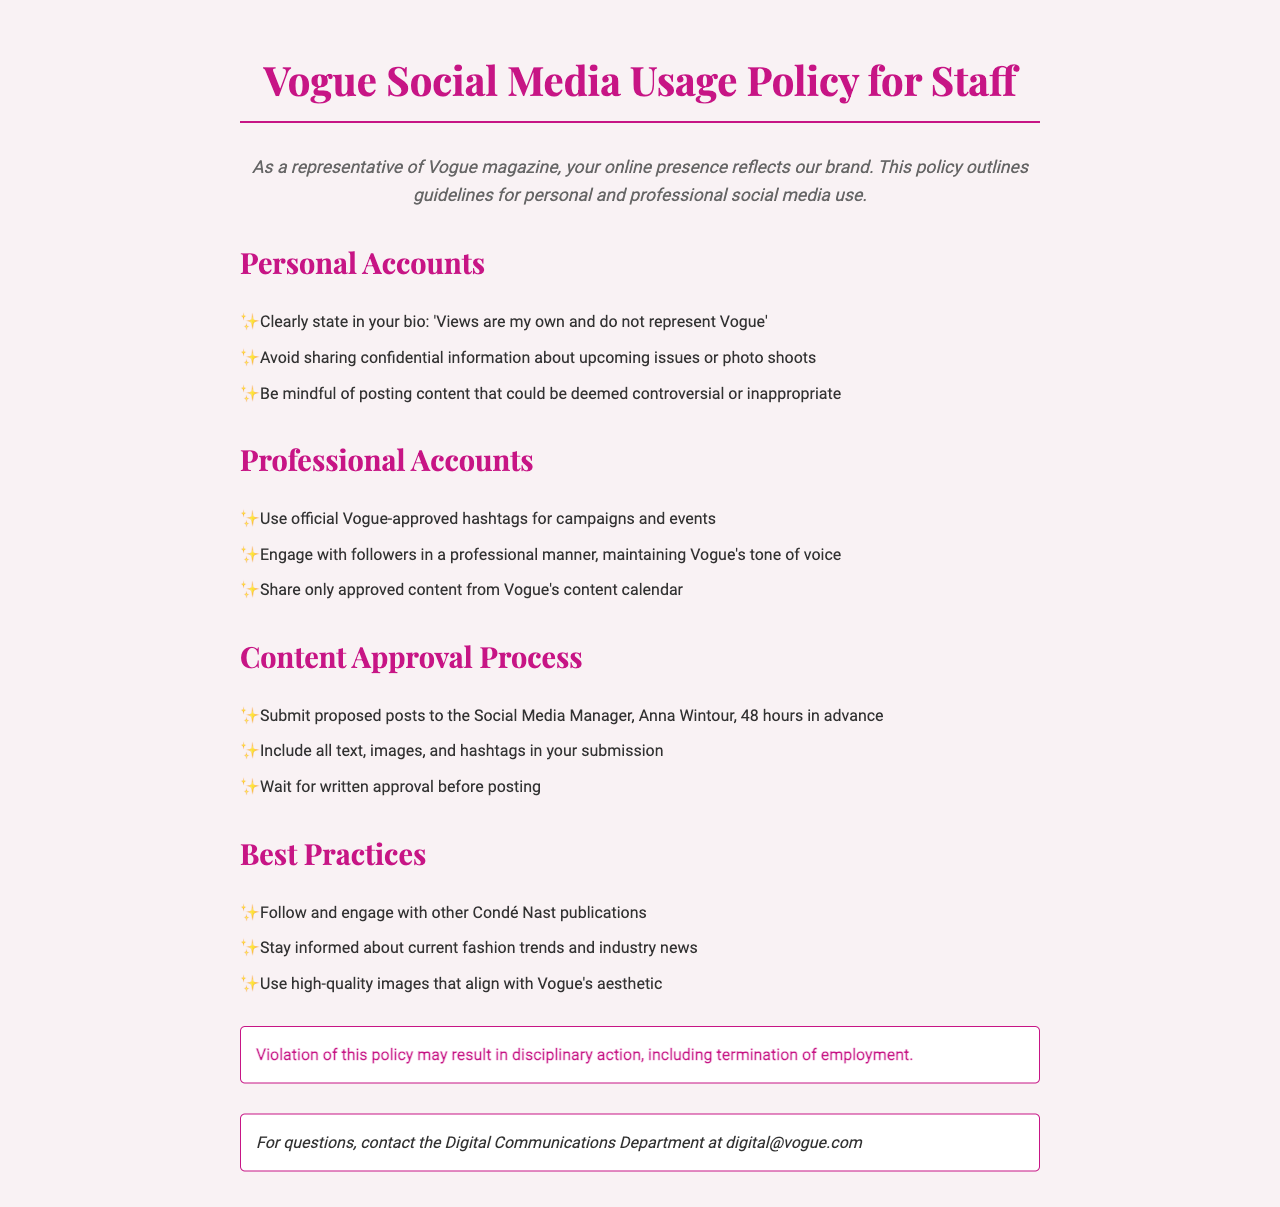What should staff include in their bio for personal accounts? Staff should clearly state 'Views are my own and do not represent Vogue' in their bio for personal accounts.
Answer: 'Views are my own and do not represent Vogue' Who must approve posts for professional accounts? The Social Media Manager, Anna Wintour, must approve posts for professional accounts.
Answer: Anna Wintour How far in advance must proposed posts be submitted? Proposed posts must be submitted 48 hours in advance.
Answer: 48 hours What must be included in the content submission? The submission must include all text, images, and hashtags.
Answer: All text, images, and hashtags What could happen if a staff member violates the policy? Violation of the policy may result in disciplinary action, including termination of employment.
Answer: Termination of employment What type of images should be used according to best practices? High-quality images that align with Vogue's aesthetic should be used.
Answer: High-quality images What should staff do to engage with followers? Staff should engage with followers in a professional manner, maintaining Vogue's tone of voice.
Answer: In a professional manner Which department should be contacted for questions? The Digital Communications Department should be contacted for questions.
Answer: Digital Communications Department 